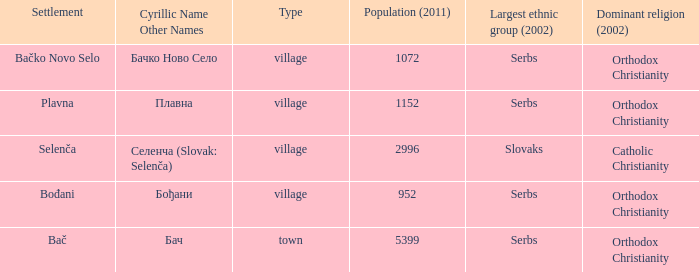What is the smallest population listed? 952.0. 